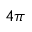Convert formula to latex. <formula><loc_0><loc_0><loc_500><loc_500>4 \pi</formula> 